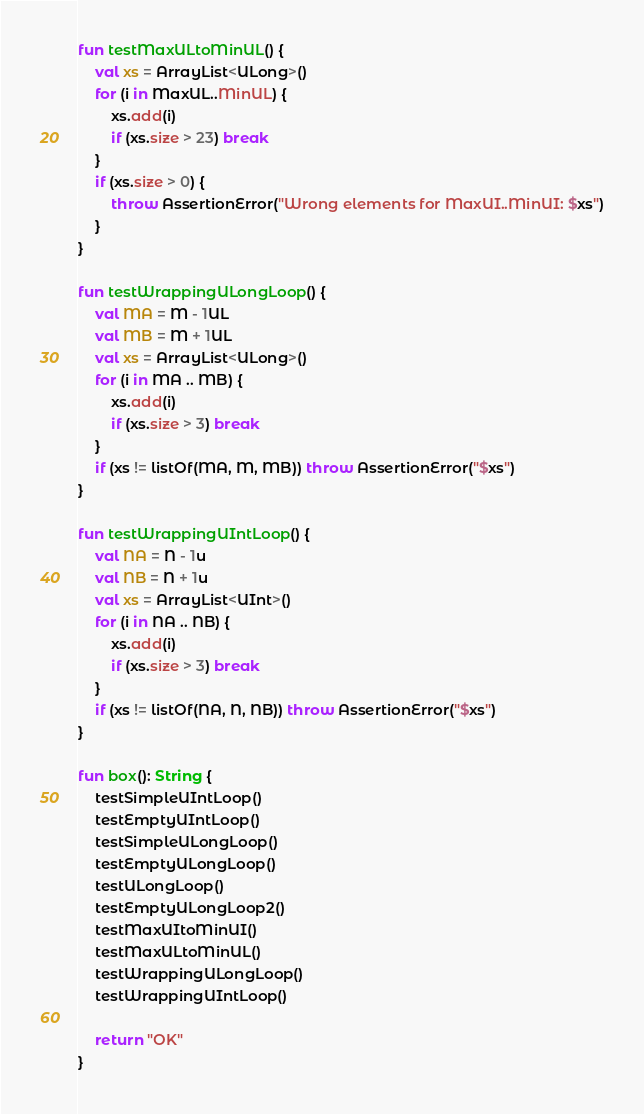Convert code to text. <code><loc_0><loc_0><loc_500><loc_500><_Kotlin_>
fun testMaxULtoMinUL() {
    val xs = ArrayList<ULong>()
    for (i in MaxUL..MinUL) {
        xs.add(i)
        if (xs.size > 23) break
    }
    if (xs.size > 0) {
        throw AssertionError("Wrong elements for MaxUI..MinUI: $xs")
    }
}

fun testWrappingULongLoop() {
    val MA = M - 1UL
    val MB = M + 1UL
    val xs = ArrayList<ULong>()
    for (i in MA .. MB) {
        xs.add(i)
        if (xs.size > 3) break
    }
    if (xs != listOf(MA, M, MB)) throw AssertionError("$xs")
}

fun testWrappingUIntLoop() {
    val NA = N - 1u
    val NB = N + 1u
    val xs = ArrayList<UInt>()
    for (i in NA .. NB) {
        xs.add(i)
        if (xs.size > 3) break
    }
    if (xs != listOf(NA, N, NB)) throw AssertionError("$xs")
}

fun box(): String {
    testSimpleUIntLoop()
    testEmptyUIntLoop()
    testSimpleULongLoop()
    testEmptyULongLoop()
    testULongLoop()
    testEmptyULongLoop2()
    testMaxUItoMinUI()
    testMaxULtoMinUL()
    testWrappingULongLoop()
    testWrappingUIntLoop()

    return "OK"
}</code> 